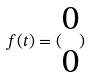<formula> <loc_0><loc_0><loc_500><loc_500>f ( t ) = ( \begin{matrix} 0 \\ 0 \end{matrix} )</formula> 